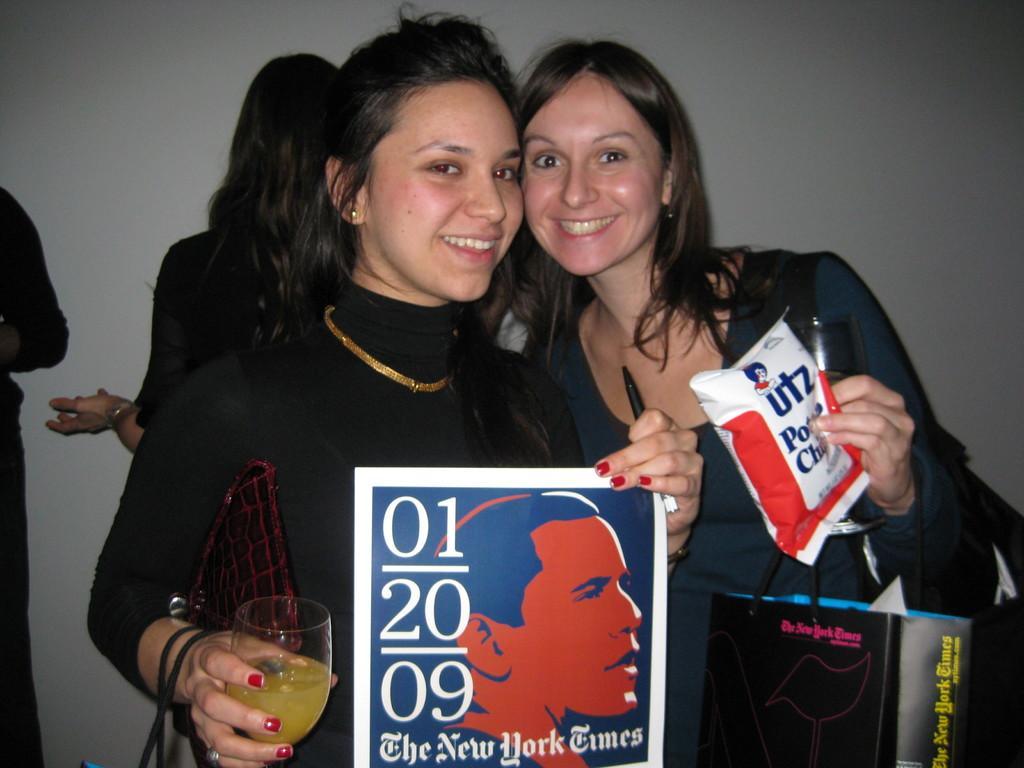How would you summarize this image in a sentence or two? In this picture two persons are standing in the middle. she hold a juice glass in her hand. And she hold a bag with her hand. And there is a poster and there is a man on this poster. Here these two persons are smiling. On the background two persons are standing. And this is the wall. 